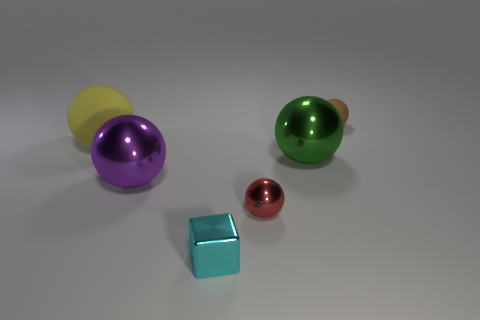What number of other objects are there of the same size as the shiny cube?
Offer a very short reply. 2. How big is the brown rubber object?
Keep it short and to the point. Small. Are the small cyan block and the sphere that is on the right side of the big green metallic thing made of the same material?
Your answer should be very brief. No. Are there any big yellow rubber things that have the same shape as the brown matte object?
Provide a succinct answer. Yes. What is the material of the yellow object that is the same size as the green metal sphere?
Your answer should be compact. Rubber. What is the size of the rubber ball on the left side of the tiny brown rubber thing?
Your answer should be very brief. Large. Is the size of the matte thing behind the large yellow object the same as the rubber thing that is in front of the brown ball?
Your response must be concise. No. How many tiny blocks have the same material as the small cyan thing?
Your answer should be compact. 0. The large matte ball is what color?
Provide a succinct answer. Yellow. There is a red object; are there any small metal blocks on the left side of it?
Your answer should be compact. Yes. 